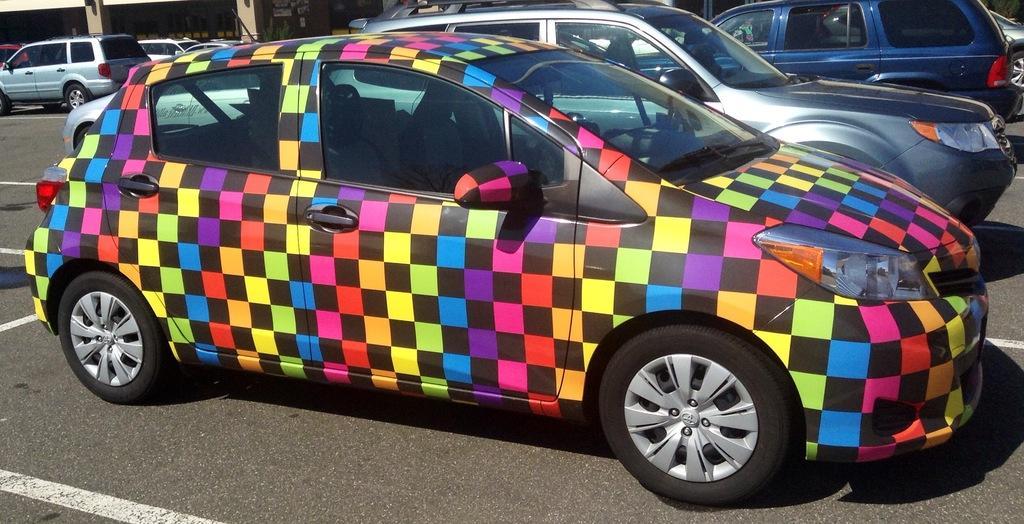Could you give a brief overview of what you see in this image? In this image we can see motor vehicles parked on the road in rows. 